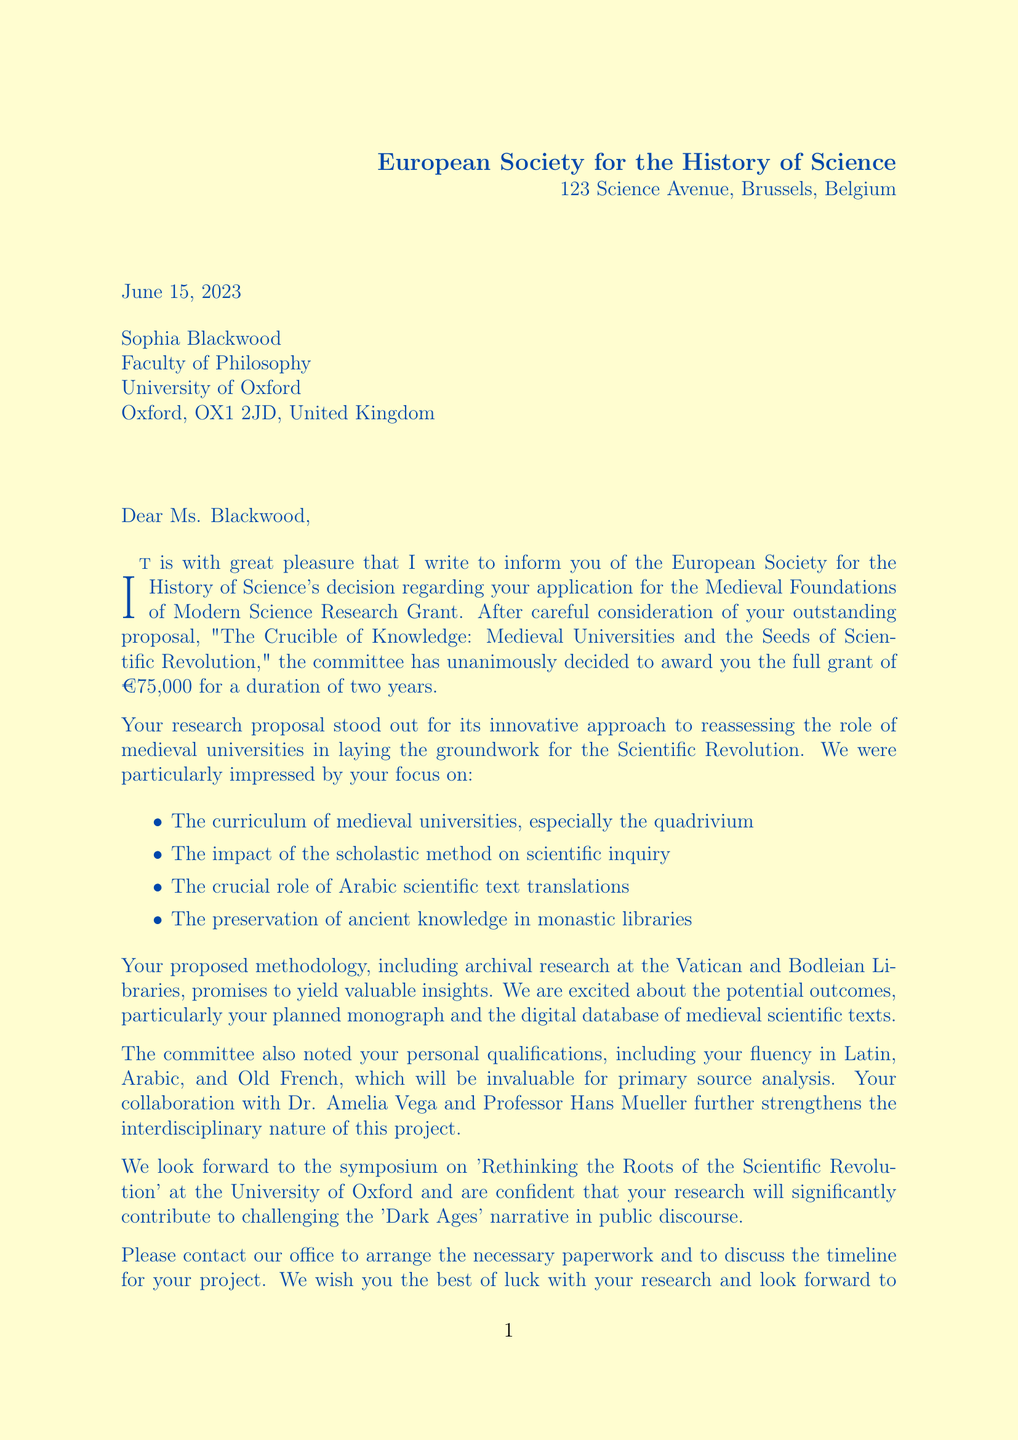What is the name of the grant awarded? The specific name of the grant awarded to Sophia Blackwood is provided in the document.
Answer: Medieval Foundations of Modern Science Research Grant Who is the recipient of the letter? The recipient of the letter is the person to whom the letter is addressed, which is mentioned at the beginning of the document.
Answer: Dr. Eleanor Hartley What is the grant amount? The document specifies the monetary value of the grant, which is an important piece of information.
Answer: €75,000 How long is the grant duration? The duration of the grant is explicitly stated in the document, indicating how long Sophia Blackwood will have funding.
Answer: 2 years What university is Sophia Blackwood affiliated with? The document notes the institution with which the applicant is associated.
Answer: University of Oxford Which two collaborators are mentioned? The document lists the names and institutions of Sophia Blackwood's collaborators, highlighting key partnerships in the research.
Answer: Dr. Amelia Vega and Professor Hans Mueller What is the primary focus area of inquiry for the research proposal? The research proposal's title hints at its main subject, indicating the central theme of the study.
Answer: Medieval universities and the seeds of scientific revolution What is one expected outcome of the research? The document outlines specific anticipated results of the research project, reflecting planned contributions to the field.
Answer: A comprehensive monograph on the role of medieval universities in fostering scientific thought What kind of research will be conducted at the Vatican Library? The document details methods and locations for research, showing where key historical documents will be examined.
Answer: Archival research What is the date the letter was written? The date at which the letter was composed is given, marking the document's time frame.
Answer: June 15, 2023 